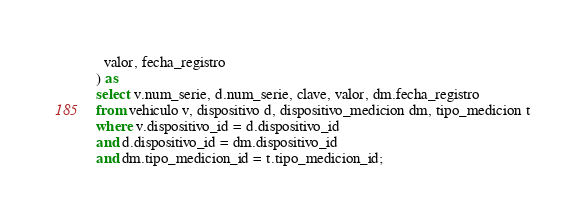<code> <loc_0><loc_0><loc_500><loc_500><_SQL_>  valor, fecha_registro 
) as 
select v.num_serie, d.num_serie, clave, valor, dm.fecha_registro
from vehiculo v, dispositivo d, dispositivo_medicion dm, tipo_medicion t
where v.dispositivo_id = d.dispositivo_id
and d.dispositivo_id = dm.dispositivo_id
and dm.tipo_medicion_id = t.tipo_medicion_id;
</code> 